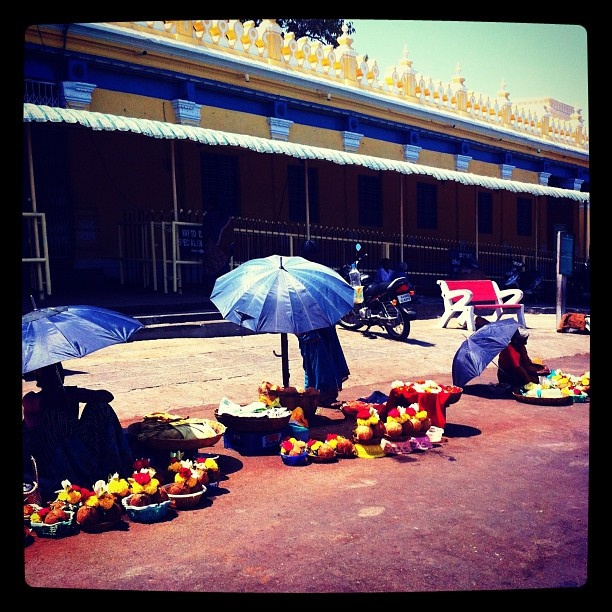Describe the objects in this image and their specific colors. I can see umbrella in black, ivory, lightblue, darkgray, and blue tones, people in black, ivory, navy, and tan tones, umbrella in black, darkgray, gray, darkblue, and blue tones, motorcycle in black, navy, white, and purple tones, and bench in black, ivory, brown, and darkgray tones in this image. 